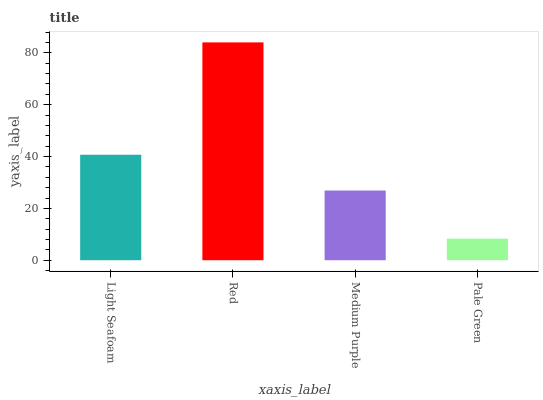Is Pale Green the minimum?
Answer yes or no. Yes. Is Red the maximum?
Answer yes or no. Yes. Is Medium Purple the minimum?
Answer yes or no. No. Is Medium Purple the maximum?
Answer yes or no. No. Is Red greater than Medium Purple?
Answer yes or no. Yes. Is Medium Purple less than Red?
Answer yes or no. Yes. Is Medium Purple greater than Red?
Answer yes or no. No. Is Red less than Medium Purple?
Answer yes or no. No. Is Light Seafoam the high median?
Answer yes or no. Yes. Is Medium Purple the low median?
Answer yes or no. Yes. Is Red the high median?
Answer yes or no. No. Is Pale Green the low median?
Answer yes or no. No. 